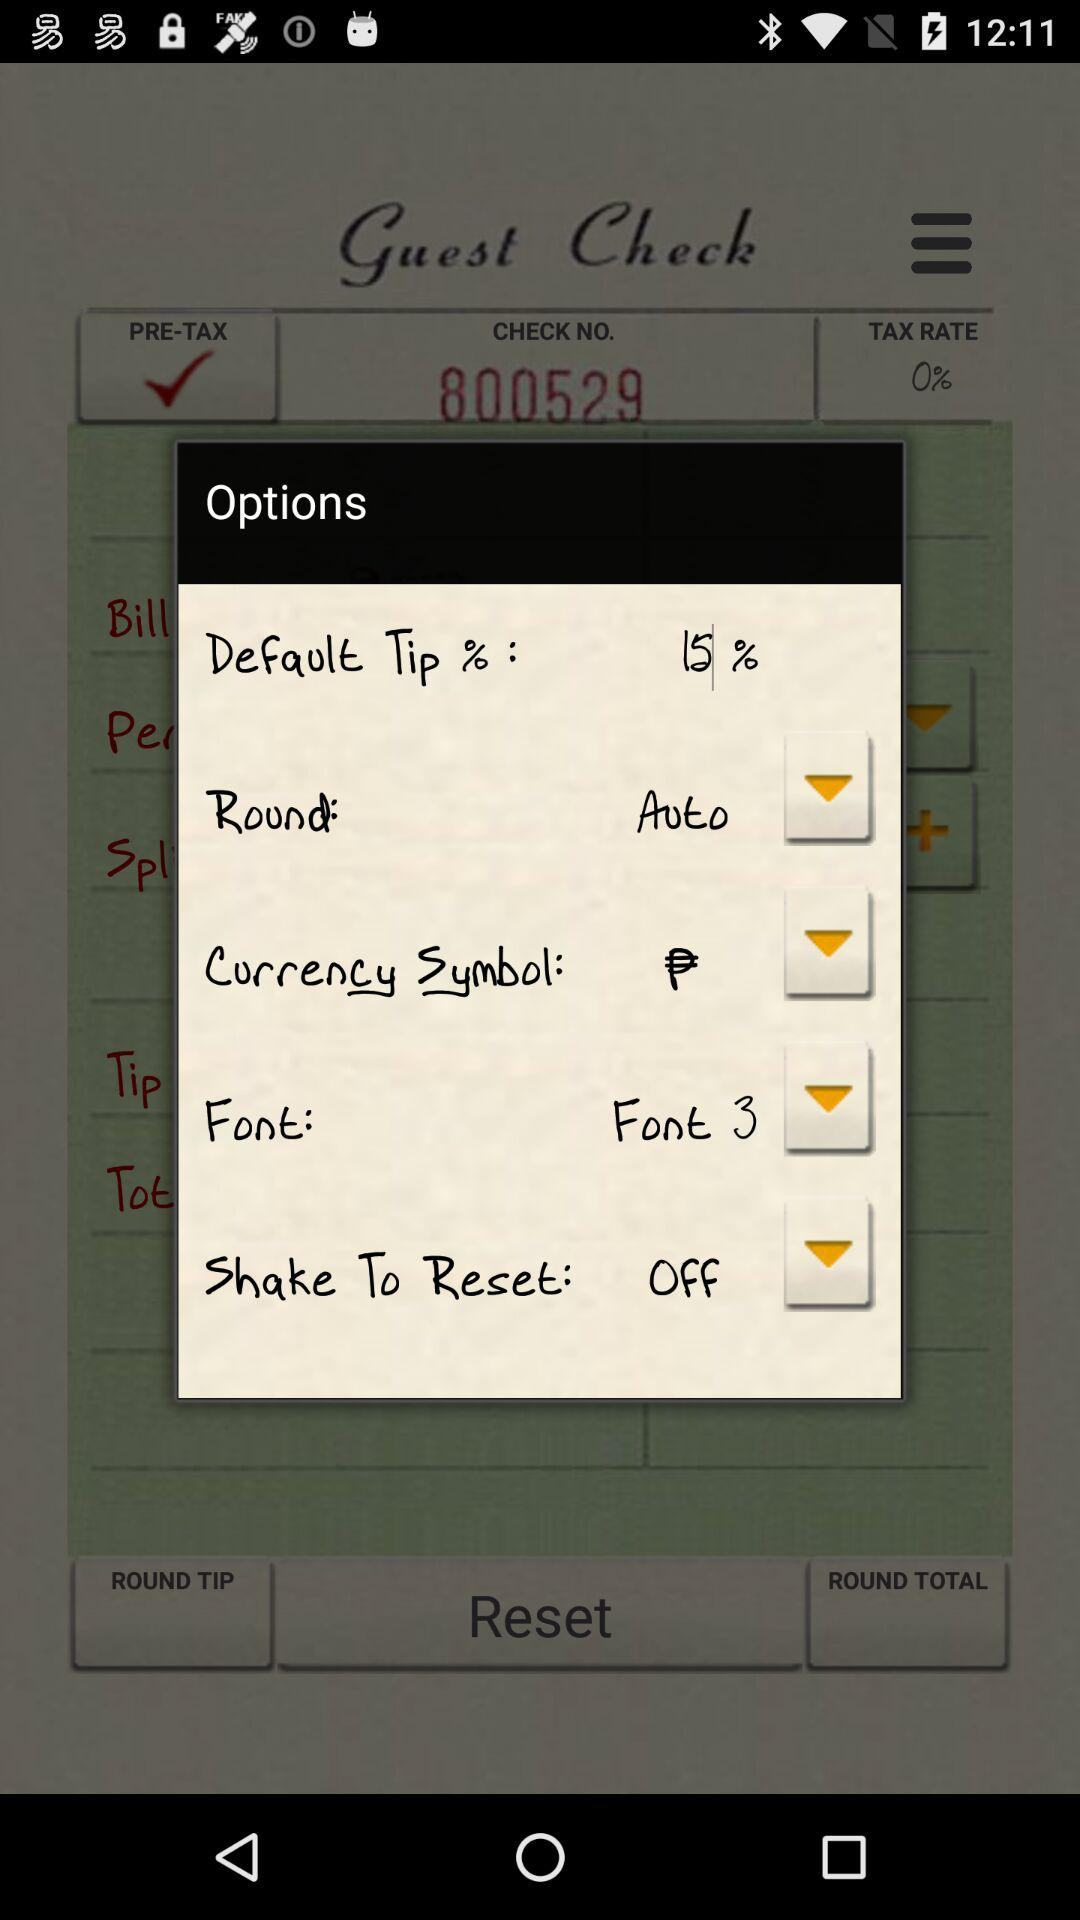What is the selected font size?
When the provided information is insufficient, respond with <no answer>. <no answer> 